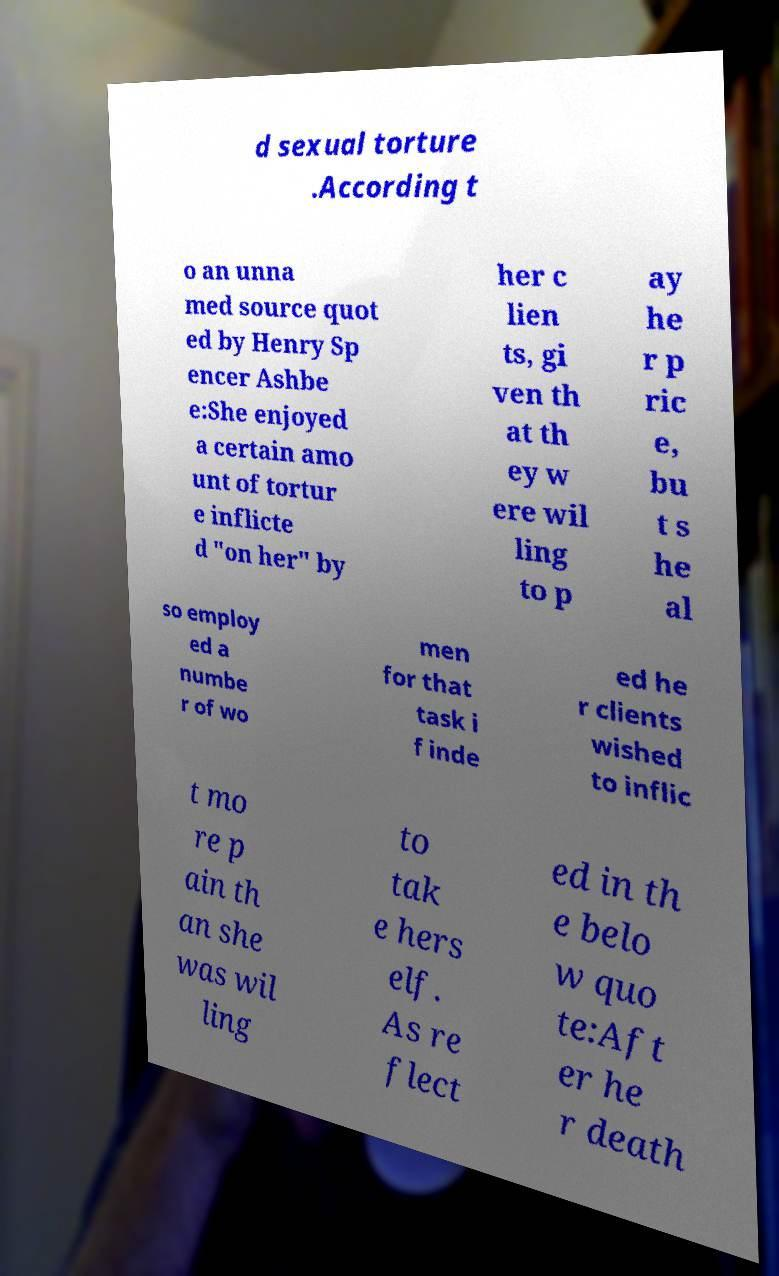What messages or text are displayed in this image? I need them in a readable, typed format. d sexual torture .According t o an unna med source quot ed by Henry Sp encer Ashbe e:She enjoyed a certain amo unt of tortur e inflicte d "on her" by her c lien ts, gi ven th at th ey w ere wil ling to p ay he r p ric e, bu t s he al so employ ed a numbe r of wo men for that task i f inde ed he r clients wished to inflic t mo re p ain th an she was wil ling to tak e hers elf. As re flect ed in th e belo w quo te:Aft er he r death 